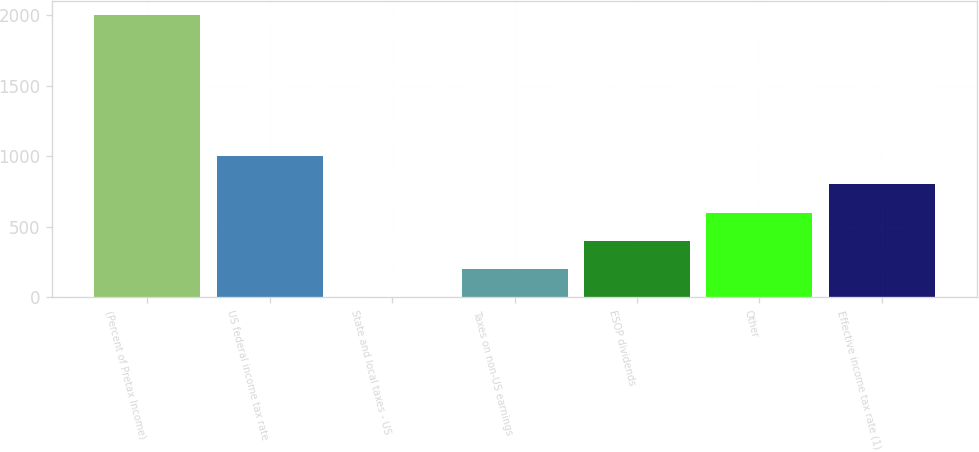<chart> <loc_0><loc_0><loc_500><loc_500><bar_chart><fcel>(Percent of Pretax Income)<fcel>US federal income tax rate<fcel>State and local taxes - US<fcel>Taxes on non-US earnings<fcel>ESOP dividends<fcel>Other<fcel>Effective income tax rate (1)<nl><fcel>2003<fcel>1002.05<fcel>1.1<fcel>201.29<fcel>401.48<fcel>601.67<fcel>801.86<nl></chart> 